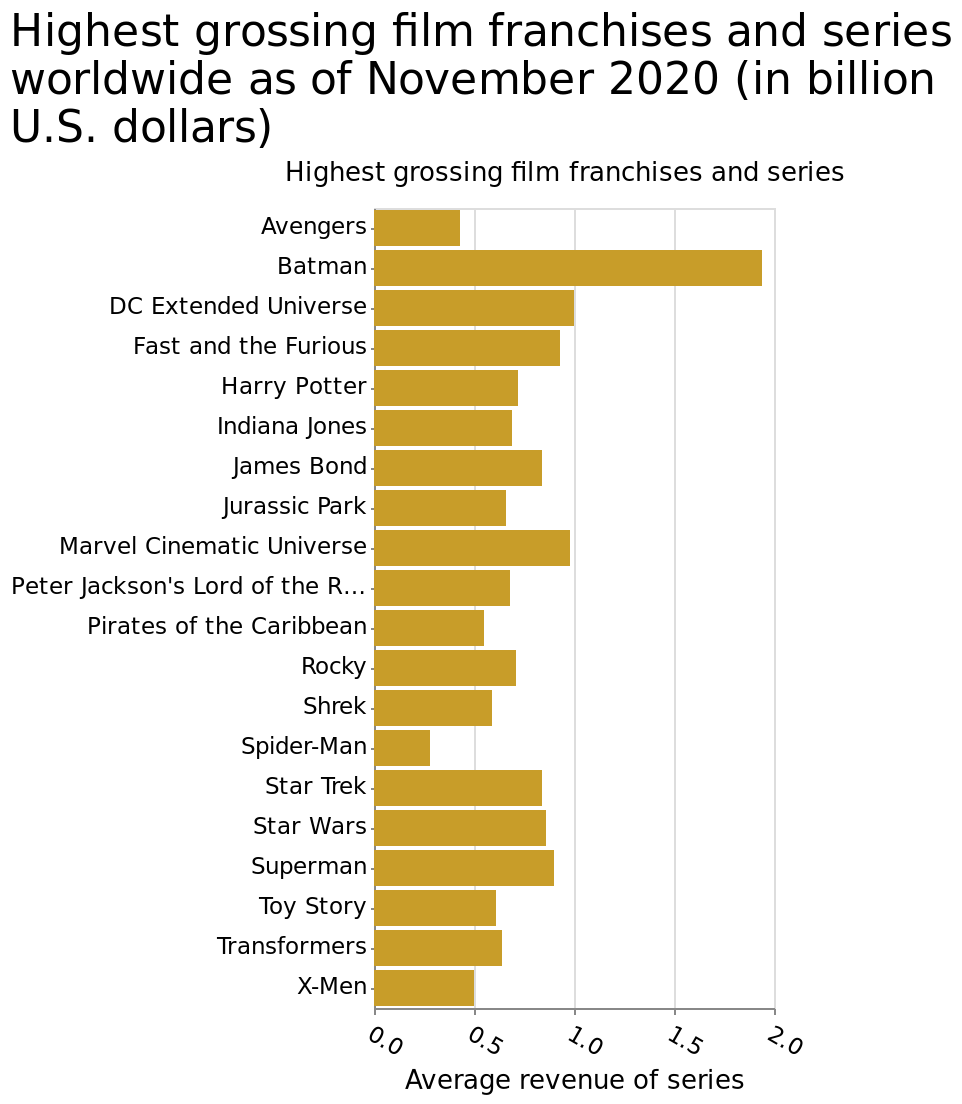<image>
please enumerates aspects of the construction of the chart This is a bar diagram titled Highest grossing film franchises and series worldwide as of November 2020 (in billion U.S. dollars). On the x-axis, Average revenue of series is plotted as a linear scale with a minimum of 0.0 and a maximum of 2.0. Highest grossing film franchises and series is defined on the y-axis. What is Batman's score? Batman's score is about 1.9. Who scores the lowest between Spiderman and Batman? Spiderman scores the lowest. 